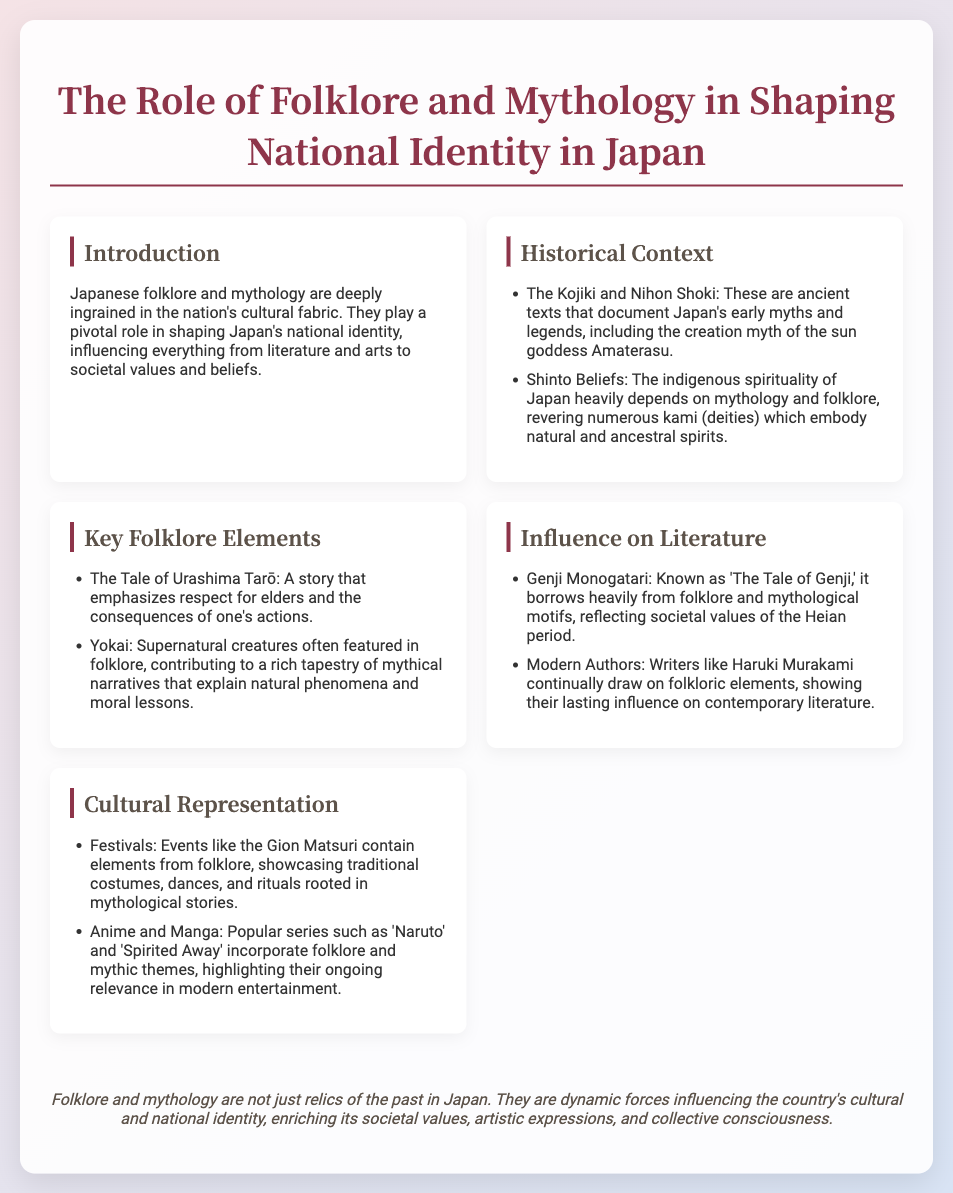What are the ancient texts that document Japan's myths? The document mentions the Kojiki and Nihon Shoki as ancient texts that document Japan's early myths and legends.
Answer: Kojiki and Nihon Shoki Which goddess is associated with Japan's creation myth? The slide refers to the sun goddess Amaterasu in relation to Japan’s creation myth.
Answer: Amaterasu What story emphasizes respect for elders? The Tale of Urashima Tarō is noted in the document for emphasizing respect for elders.
Answer: The Tale of Urashima Tarō What is the title of ‘The Tale of Genji’? The document states that Genji Monogatari is known as 'The Tale of Genji'.
Answer: The Tale of Genji Which festival is mentioned in relation to folklore? Gion Matsuri is mentioned as a festival containing elements from folklore.
Answer: Gion Matsuri How do modern authors like Haruki Murakami relate to folklore? The slide mentions that contemporary writers draw on folkloric elements, indicating their ongoing influence.
Answer: Draw on folkloric elements What influences does folklore have on contemporary entertainment? The document includes anime and manga as mediums that incorporate folklore and mythic themes.
Answer: Anime and manga What key role do folklore and mythology play in Japan's culture? The presentation emphasizes that folklore and mythology shape Japan's national identity and cultural fabric.
Answer: Shape national identity What is a key aspect of Shinto beliefs? The document mentions that Shinto beliefs heavily depend on mythology and folklore.
Answer: Heavily depend on mythology and folklore 